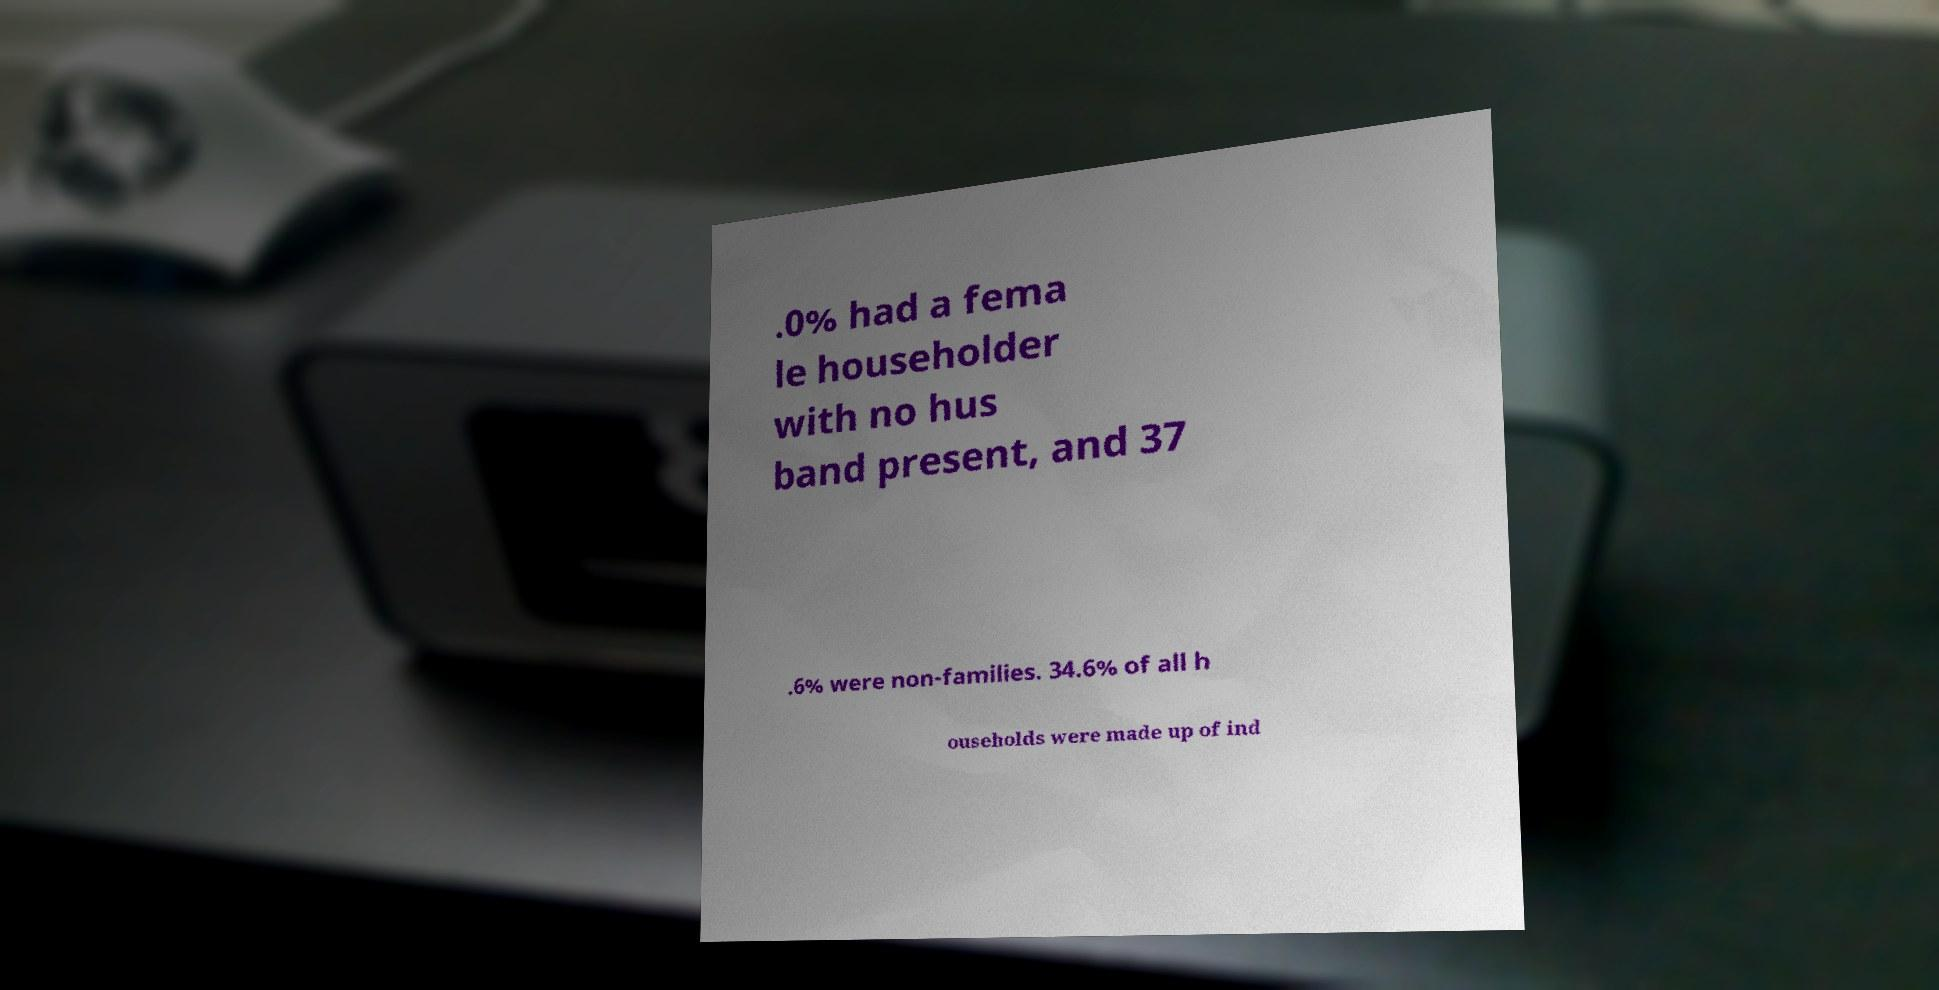Can you read and provide the text displayed in the image?This photo seems to have some interesting text. Can you extract and type it out for me? .0% had a fema le householder with no hus band present, and 37 .6% were non-families. 34.6% of all h ouseholds were made up of ind 